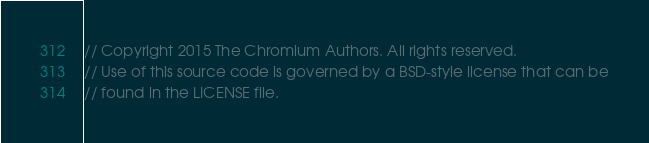<code> <loc_0><loc_0><loc_500><loc_500><_ObjectiveC_>// Copyright 2015 The Chromium Authors. All rights reserved.
// Use of this source code is governed by a BSD-style license that can be
// found in the LICENSE file.
</code> 